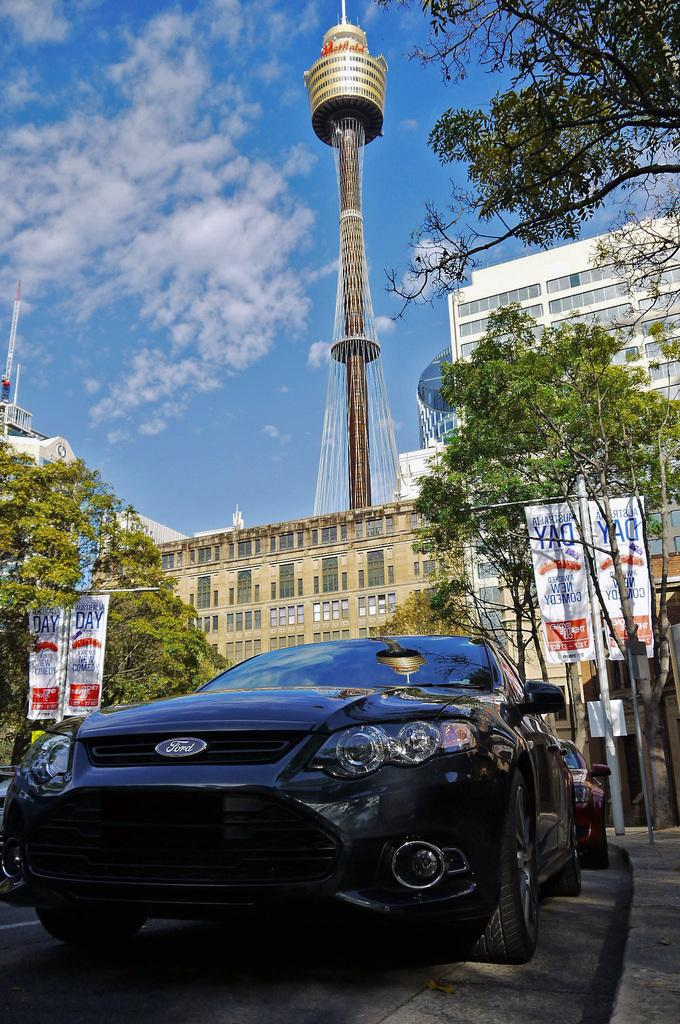What can be seen on the road in the image? There are vehicles on the road in the image. What type of natural elements are visible in the image? There are trees visible in the image. What are the banners attached to in the image? The banners are attached to poles in the image. What type of man-made structures can be seen in the image? There are buildings and towers in the image. What is visible in the sky in the image? There are clouds in the sky in the image. What type of straw is being used for the dinner in the image? There is no straw or dinner present in the image; it features vehicles on the road, trees, banners, buildings, towers, and clouds in the sky. What items are on the list that is visible in the image? There is no list present in the image. 